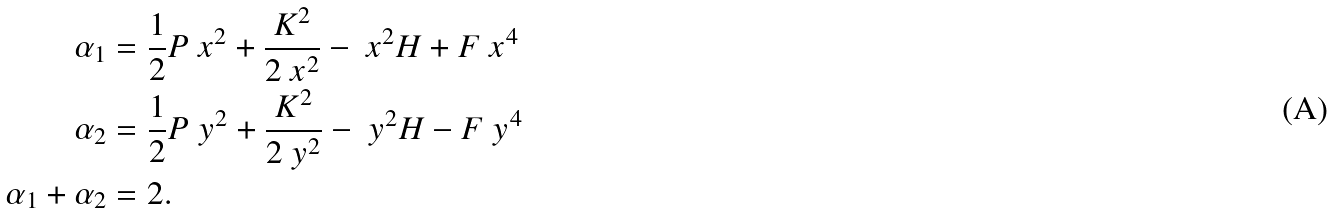Convert formula to latex. <formula><loc_0><loc_0><loc_500><loc_500>\alpha _ { 1 } & = \frac { 1 } { 2 } P _ { \ } x ^ { 2 } + \frac { K ^ { 2 } } { 2 \ x ^ { 2 } } - \ x ^ { 2 } H + F \ x ^ { 4 } \\ \alpha _ { 2 } & = \frac { 1 } { 2 } P _ { \ } y ^ { 2 } + \frac { K ^ { 2 } } { 2 \ y ^ { 2 } } - \ y ^ { 2 } H - F \ y ^ { 4 } \\ \alpha _ { 1 } + \alpha _ { 2 } & = 2 .</formula> 